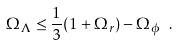<formula> <loc_0><loc_0><loc_500><loc_500>\Omega _ { \Lambda } \leq \frac { 1 } { 3 } ( 1 + \Omega _ { r } ) - \Omega _ { \phi } \ .</formula> 